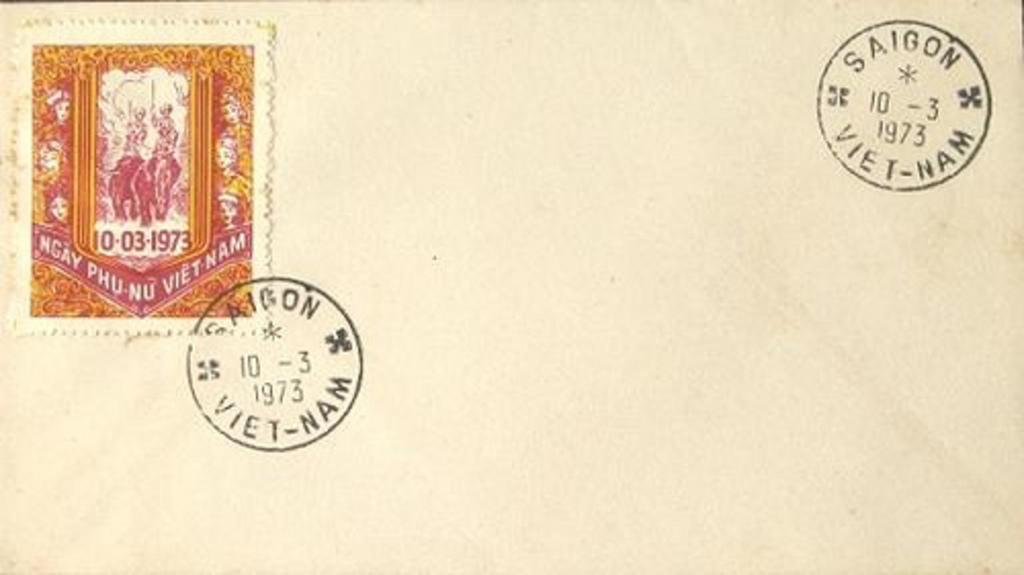What date is on the card?
Provide a succinct answer. 10-03-1973. 